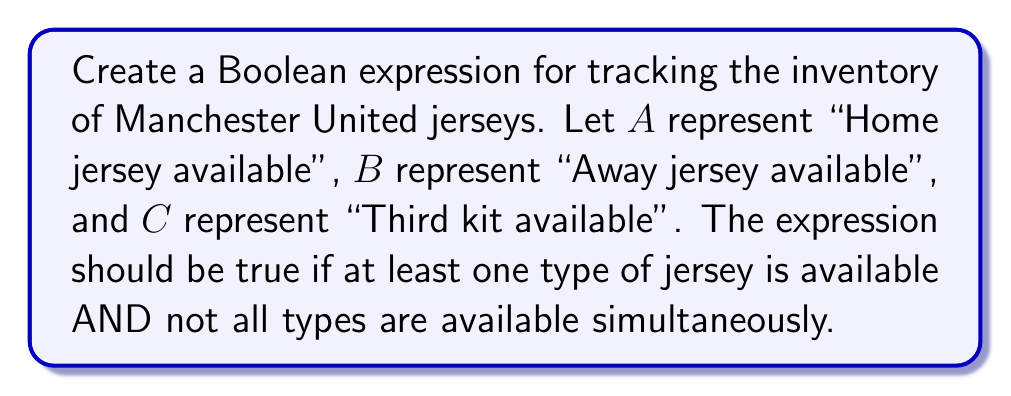Could you help me with this problem? Let's approach this step-by-step:

1) First, we need an expression that is true if at least one type of jersey is available:
   $A \lor B \lor C$

2) Next, we need an expression that is false if all types are available simultaneously:
   $\lnot(A \land B \land C)$

3) We want both conditions to be true, so we combine them with AND:
   $(A \lor B \lor C) \land \lnot(A \land B \land C)$

4) We can simplify $\lnot(A \land B \land C)$ using De Morgan's law:
   $\lnot(A \land B \land C) \equiv \lnot A \lor \lnot B \lor \lnot C$

5) Substituting this back into our expression:
   $(A \lor B \lor C) \land (\lnot A \lor \lnot B \lor \lnot C)$

This Boolean expression will be true if at least one type of Manchester United jersey is available in the inventory, but not all types are available at the same time.
Answer: $(A \lor B \lor C) \land (\lnot A \lor \lnot B \lor \lnot C)$ 